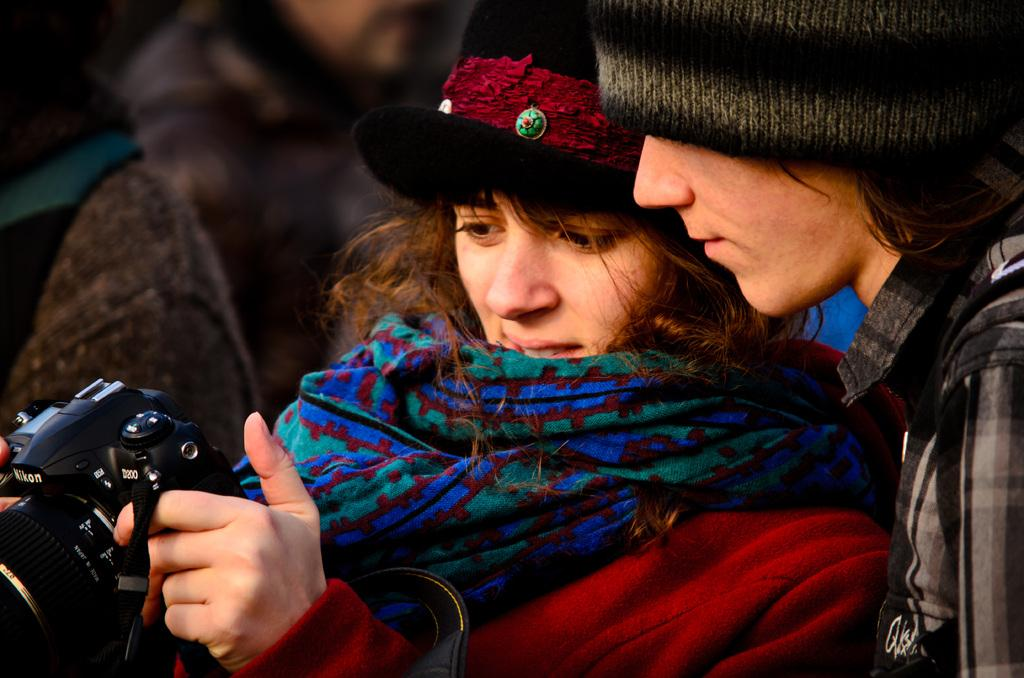How many people are in the image? There are two people in the image, a man and a woman. What are the man and woman wearing on their heads? The man and woman are both wearing caps. What is the woman holding in her hand? The woman is holding a camera in her hand. What are the man and woman doing in the image? The man and woman are looking at the camera. How would you describe the background of the image? The background of the image is blurry. What type of taste can be experienced from the scene in the image? There is no taste associated with the scene in the image, as it is a photograph and not an edible item. 